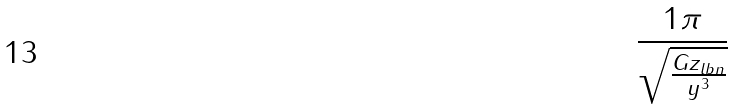Convert formula to latex. <formula><loc_0><loc_0><loc_500><loc_500>\frac { 1 \pi } { \sqrt { \frac { G z _ { l b n } } { y ^ { 3 } } } }</formula> 